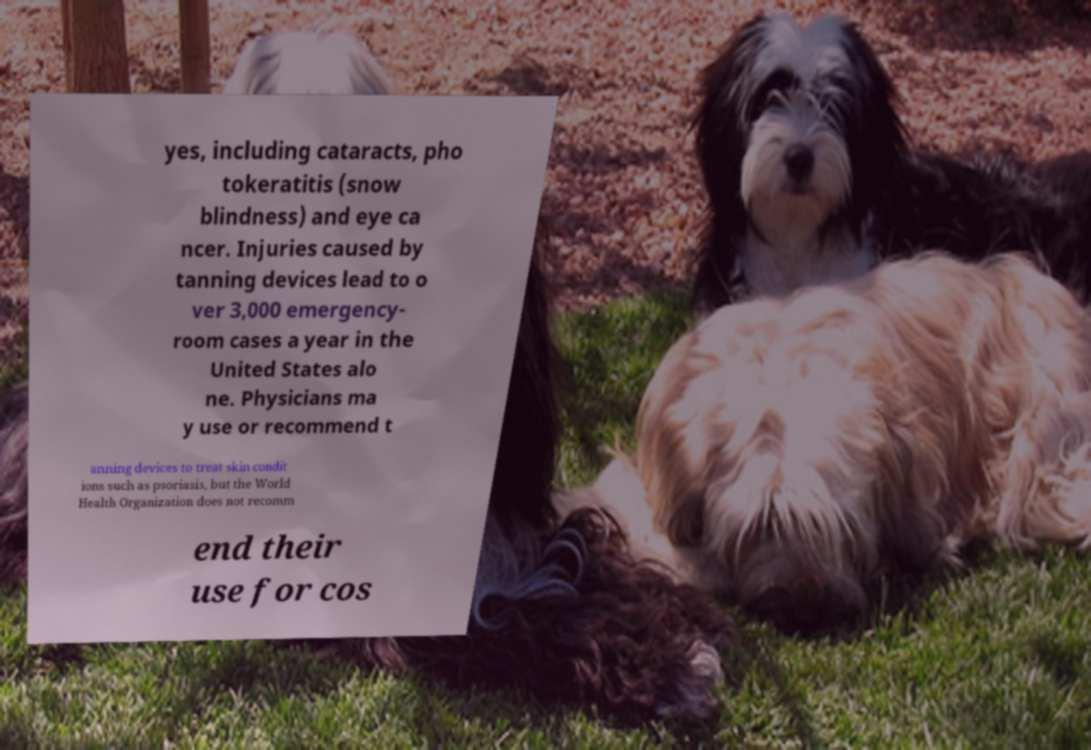Could you extract and type out the text from this image? yes, including cataracts, pho tokeratitis (snow blindness) and eye ca ncer. Injuries caused by tanning devices lead to o ver 3,000 emergency- room cases a year in the United States alo ne. Physicians ma y use or recommend t anning devices to treat skin condit ions such as psoriasis, but the World Health Organization does not recomm end their use for cos 